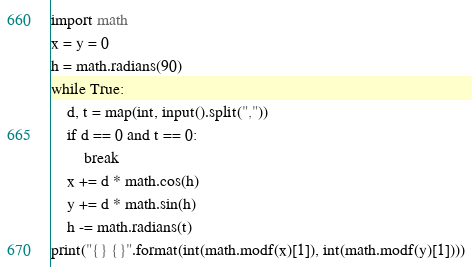Convert code to text. <code><loc_0><loc_0><loc_500><loc_500><_Python_>import math
x = y = 0
h = math.radians(90)
while True:
    d, t = map(int, input().split(","))
    if d == 0 and t == 0:
        break
    x += d * math.cos(h)
    y += d * math.sin(h)
    h -= math.radians(t)
print("{} {}".format(int(math.modf(x)[1]), int(math.modf(y)[1])))
</code> 